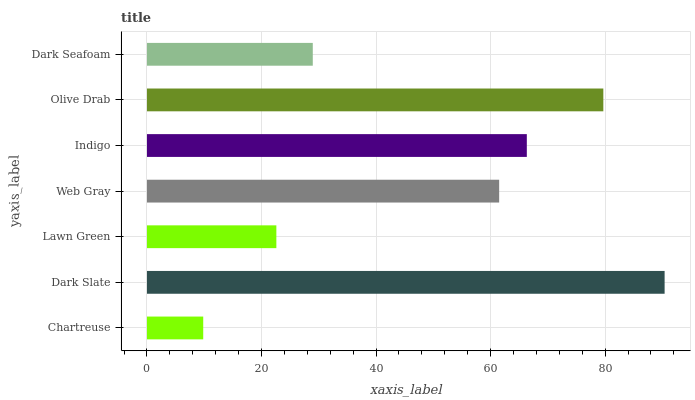Is Chartreuse the minimum?
Answer yes or no. Yes. Is Dark Slate the maximum?
Answer yes or no. Yes. Is Lawn Green the minimum?
Answer yes or no. No. Is Lawn Green the maximum?
Answer yes or no. No. Is Dark Slate greater than Lawn Green?
Answer yes or no. Yes. Is Lawn Green less than Dark Slate?
Answer yes or no. Yes. Is Lawn Green greater than Dark Slate?
Answer yes or no. No. Is Dark Slate less than Lawn Green?
Answer yes or no. No. Is Web Gray the high median?
Answer yes or no. Yes. Is Web Gray the low median?
Answer yes or no. Yes. Is Chartreuse the high median?
Answer yes or no. No. Is Dark Slate the low median?
Answer yes or no. No. 